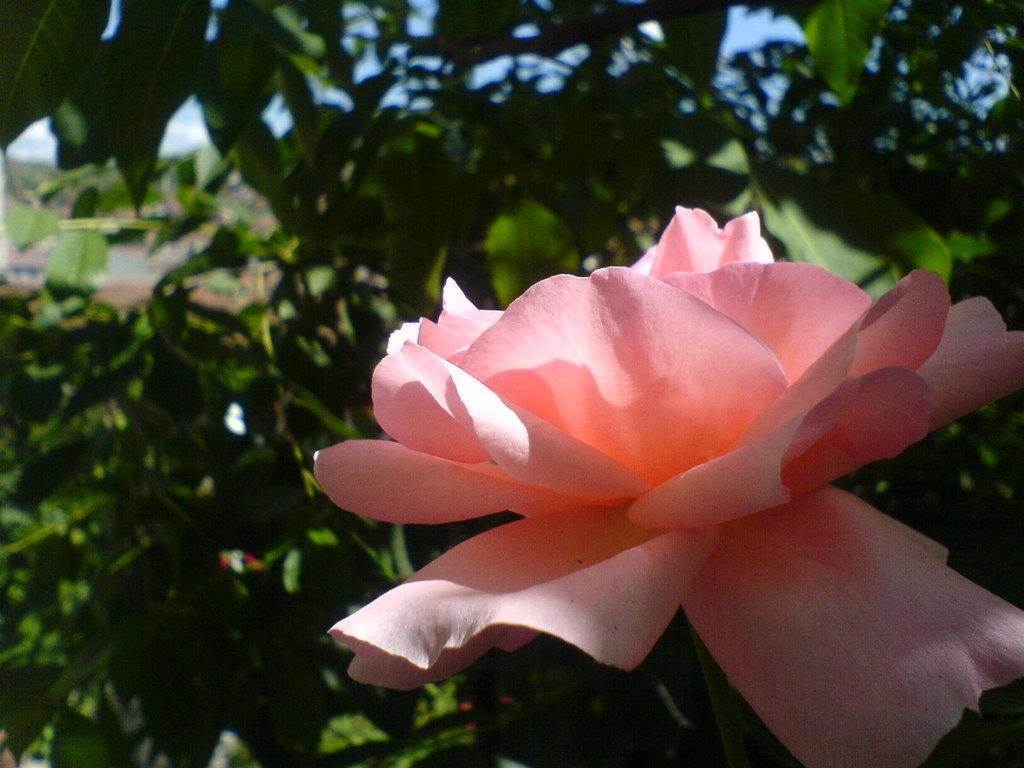What type of plant can be seen in the image? There is a flower in the image. Are there any other plants visible in the image? Yes, there are plants in the image. Can you describe the background of the image? The background of the image is blurry. How many things are on fire in the image? There is no fire or any objects on fire present in the image. 